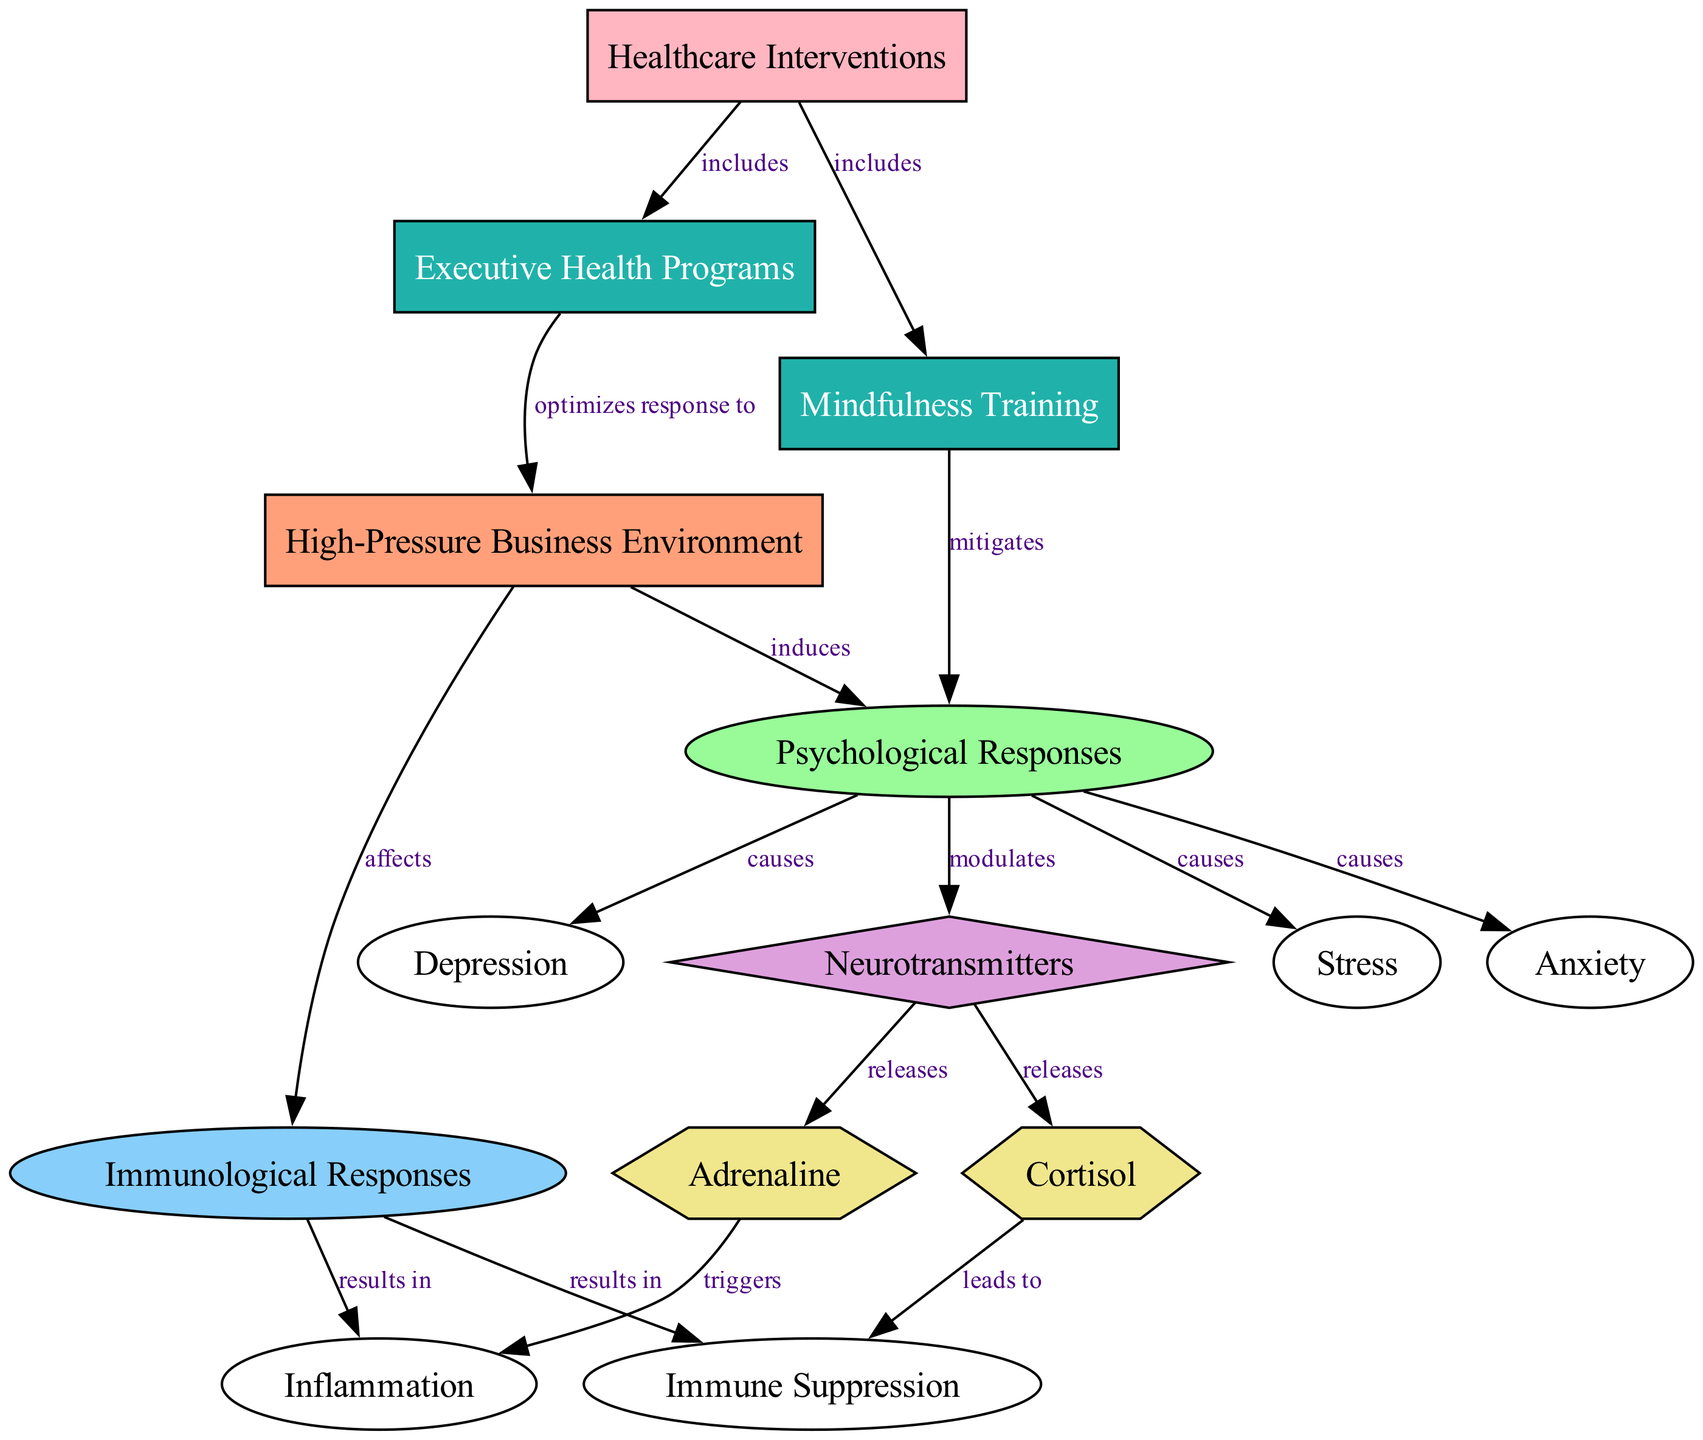What induces psychological responses in a high-pressure business environment? The diagram shows that "High-Pressure Business Environment" induces "Psychological Responses." This is represented by the directed edge labeled "induces" connecting node 1 (High-Pressure Business Environment) to node 2 (Psychological Responses).
Answer: Psychological responses What causes anxiety in the context of occupational stress? According to the diagram, "Stress" causes "Anxiety." This relationship can be traced from node 8 (Stress) to node 9 (Anxiety) with the edge labeled "causes."
Answer: Stress How many nodes are related to immune system responses? The diagram indicates that there are three nodes related to immunological responses, specifically "Immunological Responses," "Immune Suppression," and "Inflammation." These are nodes 3, 11, and 12.
Answer: Three What neurotransmitters are released as a psychological response? The diagram specifies that both "Cortisol" and "Adrenaline" are released in response to neurotransmitters, indicated by the edges labeled "releases" connecting node 4 (Neurotransmitters) to nodes 5 (Cortisol) and 6 (Adrenaline).
Answer: Cortisol and Adrenaline Which healthcare interventions optimize the response to high-pressure business environments? The diagram reveals that "Executive Health Programs" include interventions that optimize the response to "High-Pressure Business Environment," as shown by the edge labeled "optimizes response to" from node 13 (Executive Health Programs) to node 1 (High-Pressure Business Environment).
Answer: Executive Health Programs What is the primary negative impact of cortisol release according to the diagram? It is clear from the diagram that "Cortisol" leads to "Immune Suppression." Following the directed edge labeled "leads to," one can deduce the negative impact of cortisol.
Answer: Immune suppression How do mindfulness training and executive health programs relate to psychological responses? The diagram illustrates that "Mindfulness Training" mitigates "Psychological Responses," as indicated by the edge labeled "mitigates" from node 14 (Mindfulness Training) to node 2 (Psychological Responses). Furthermore, "Executive Health Programs" includes strategies that optimize responses to occupational stress, shown by node 13 (Executive Health Programs) connecting to node 1 (High-Pressure Business Environment) with the edge labeled "optimizes response to." Together, they provide support for finding balance in high-pressure situations.
Answer: Mindfulness Training and Executive Health Programs What results from immunological responses in high-pressure environments? The diagram illustrates that "Immunological Responses" results in both "Immune Suppression" and "Inflammation," as indicated by the directed edges from node 3 (Immunological Responses) to nodes 11 (Immune Suppression) and 12 (Inflammation) labeled "results in."
Answer: Immune suppression and Inflammation 